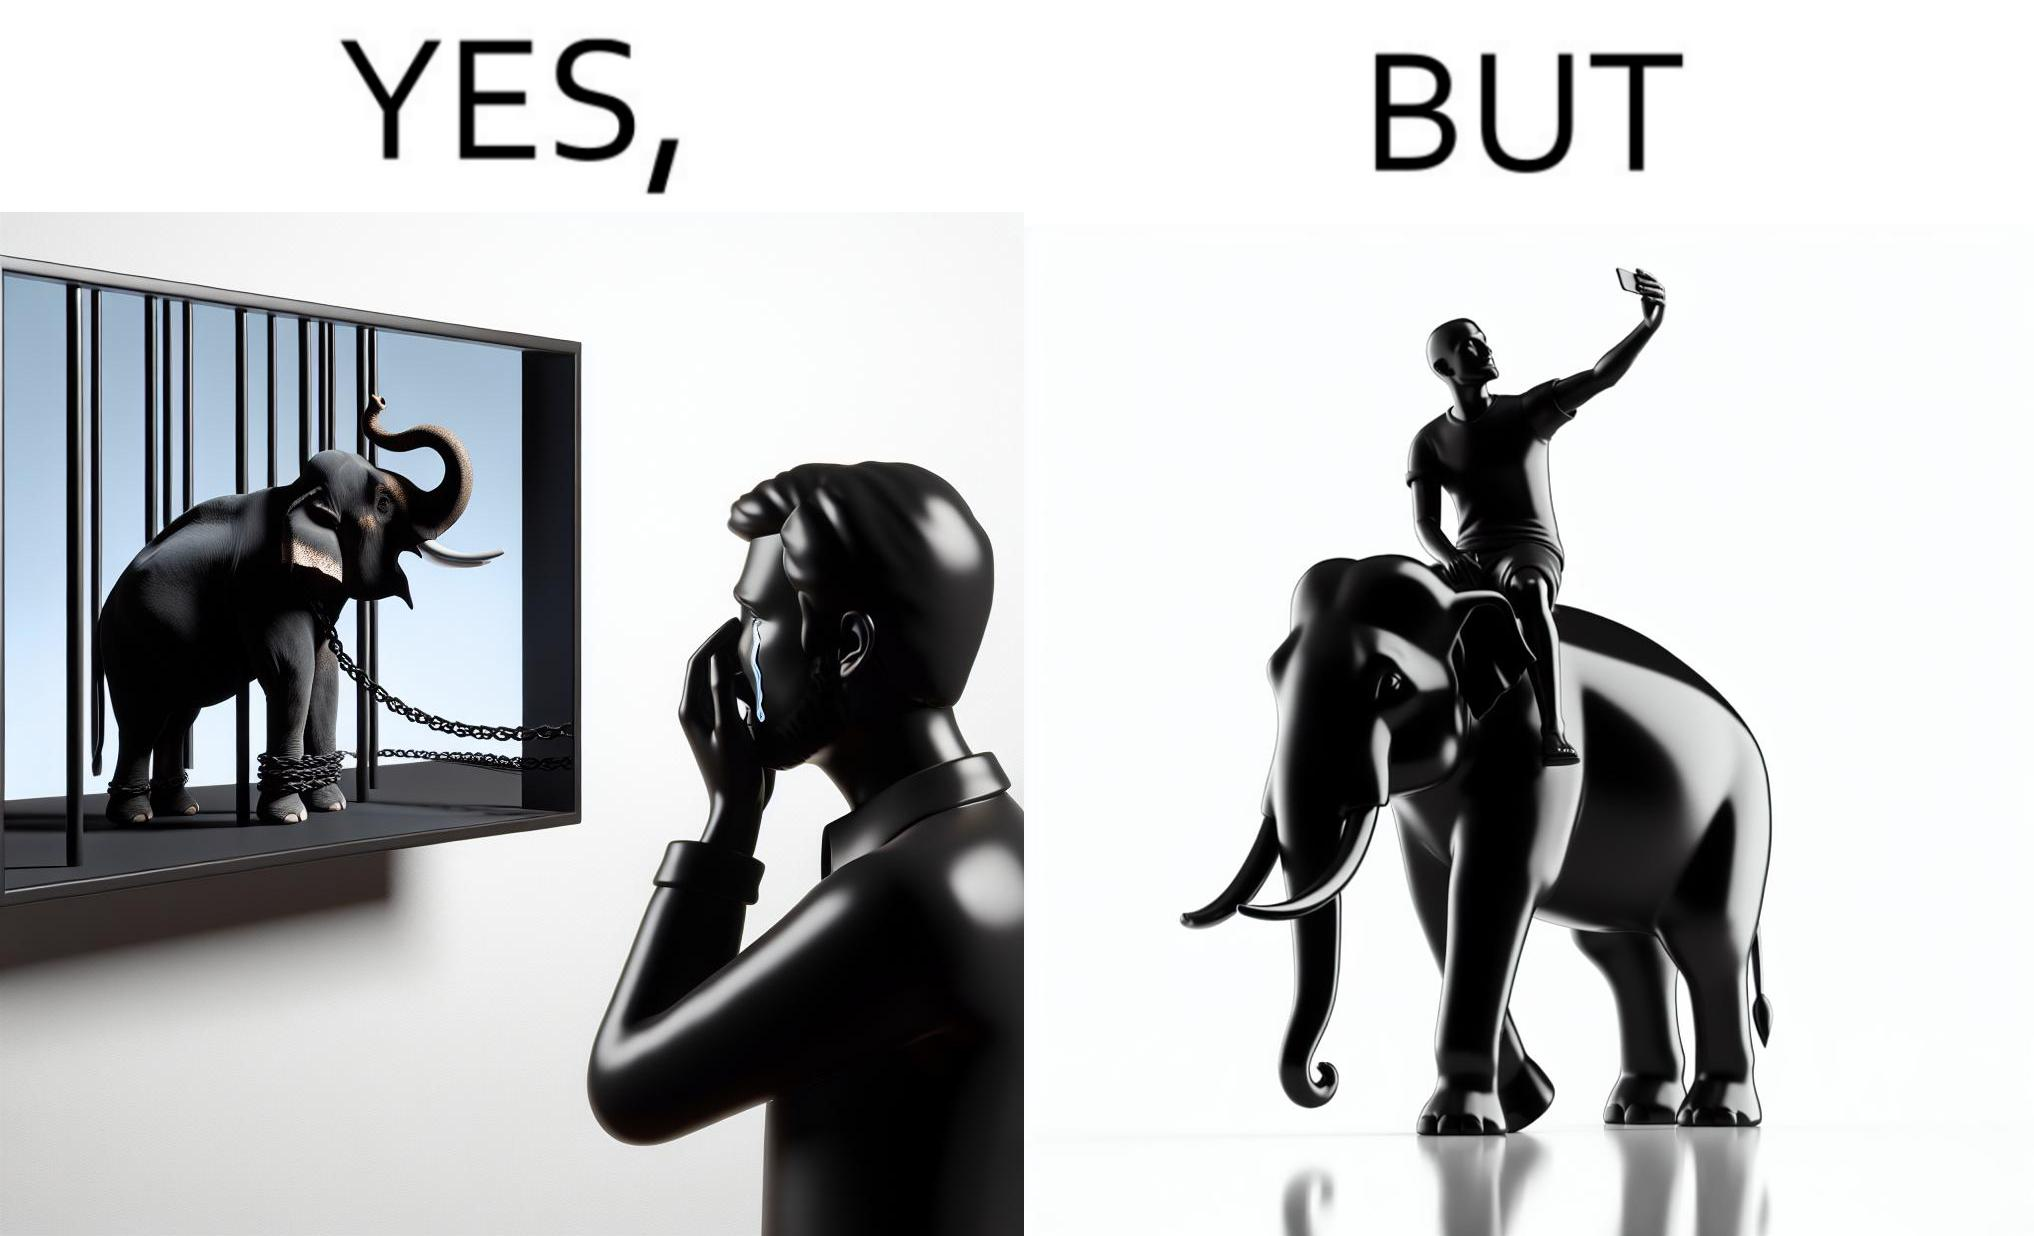What is shown in this image? The image is ironic, because the people who get sentimental over imprisoned animal while watching TV shows often feel okay when using animals for labor 